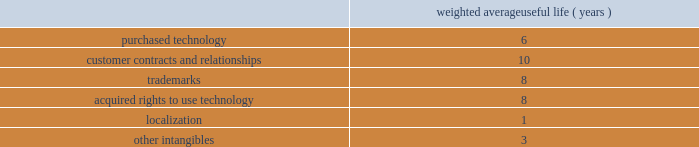Adobe systems incorporated notes to consolidated financial statements ( continued ) we review our goodwill for impairment annually , or more frequently , if facts and circumstances warrant a review .
We completed our annual impairment test in the second quarter of fiscal 2014 .
We elected to use the step 1 quantitative assessment for our reporting units and determined that there was no impairment of goodwill .
There is no significant risk of material goodwill impairment in any of our reporting units , based upon the results of our annual goodwill impairment test .
We amortize intangible assets with finite lives over their estimated useful lives and review them for impairment whenever an impairment indicator exists .
We continually monitor events and changes in circumstances that could indicate carrying amounts of our long-lived assets , including our intangible assets may not be recoverable .
When such events or changes in circumstances occur , we assess recoverability by determining whether the carrying value of such assets will be recovered through the undiscounted expected future cash flows .
If the future undiscounted cash flows are less than the carrying amount of these assets , we recognize an impairment loss based on any excess of the carrying amount over the fair value of the assets .
We did not recognize any intangible asset impairment charges in fiscal 2014 , 2013 or 2012 .
Our intangible assets are amortized over their estimated useful lives of 1 to 14 years .
Amortization is based on the pattern in which the economic benefits of the intangible asset will be consumed or on a straight-line basis when the consumption pattern is not apparent .
The weighted average useful lives of our intangible assets were as follows : weighted average useful life ( years ) .
Software development costs capitalization of software development costs for software to be sold , leased , or otherwise marketed begins upon the establishment of technological feasibility , which is generally the completion of a working prototype that has been certified as having no critical bugs and is a release candidate .
Amortization begins once the software is ready for its intended use , generally based on the pattern in which the economic benefits will be consumed .
To date , software development costs incurred between completion of a working prototype and general availability of the related product have not been material .
Internal use software we capitalize costs associated with customized internal-use software systems that have reached the application development stage .
Such capitalized costs include external direct costs utilized in developing or obtaining the applications and payroll and payroll-related expenses for employees , who are directly associated with the development of the applications .
Capitalization of such costs begins when the preliminary project stage is complete and ceases at the point in which the project is substantially complete and is ready for its intended purpose .
Income taxes we use the asset and liability method of accounting for income taxes .
Under this method , income tax expense is recognized for the amount of taxes payable or refundable for the current year .
In addition , deferred tax assets and liabilities are recognized for expected future tax consequences of temporary differences between the financial reporting and tax bases of assets and liabilities , and for operating losses and tax credit carryforwards .
We record a valuation allowance to reduce deferred tax assets to an amount for which realization is more likely than not .
Taxes collected from customers we net taxes collected from customers against those remitted to government authorities in our financial statements .
Accordingly , taxes collected from customers are not reported as revenue. .
Is the weighted average useful life ( years ) greater for purchased technology than customer contracts and relationships? 
Computations: (6 > 10)
Answer: no. 